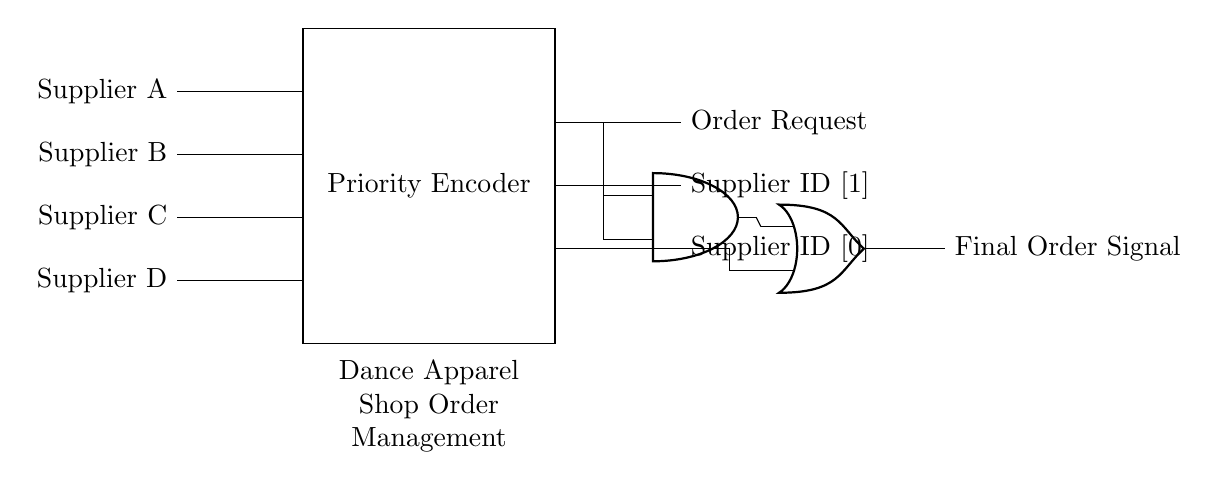What components are present in the circuit? The circuit contains input lines from suppliers, a priority encoder, an AND gate, and an OR gate.
Answer: Input lines, priority encoder, AND gate, OR gate What signal does the priority encoder output? The priority encoder provides the output for the order request and supplier ID, ensuring that the highest priority order request is processed first.
Answer: Order request, Supplier ID How many suppliers are handled by the circuit? The circuit handles four suppliers as evidenced by the four input lines labeled Supplier A through Supplier D.
Answer: Four suppliers What type of logical operation does the AND gate perform in this circuit? The AND gate combines inputs to determine when both output signals from the priority encoder are high, indicating a valid order request from a supplier.
Answer: Logical AND Which supplier has the highest priority based on the circuit connections? Supplier A is at the top of the input lines, indicating it has the highest priority among the suppliers in the order management process.
Answer: Supplier A What is the final output from the OR gate? The OR gate combines the signals from the AND gate and the direct connection from Supplier D to produce a final order signal based on those inputs.
Answer: Final Order Signal 